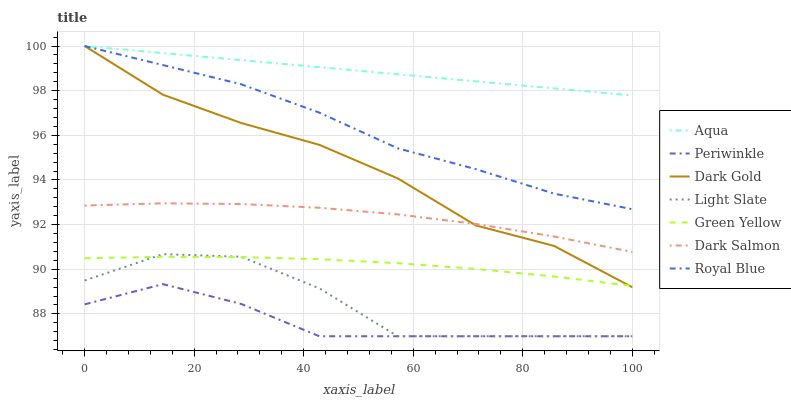Does Light Slate have the minimum area under the curve?
Answer yes or no. No. Does Light Slate have the maximum area under the curve?
Answer yes or no. No. Is Light Slate the smoothest?
Answer yes or no. No. Is Aqua the roughest?
Answer yes or no. No. Does Aqua have the lowest value?
Answer yes or no. No. Does Light Slate have the highest value?
Answer yes or no. No. Is Periwinkle less than Royal Blue?
Answer yes or no. Yes. Is Dark Gold greater than Periwinkle?
Answer yes or no. Yes. Does Periwinkle intersect Royal Blue?
Answer yes or no. No. 